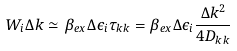<formula> <loc_0><loc_0><loc_500><loc_500>W _ { i } \Delta k \simeq \beta _ { e x } \Delta \epsilon _ { i } \tau _ { k k } = \beta _ { e x } \Delta \epsilon _ { i } \frac { \Delta k ^ { 2 } } { 4 D _ { k k } }</formula> 